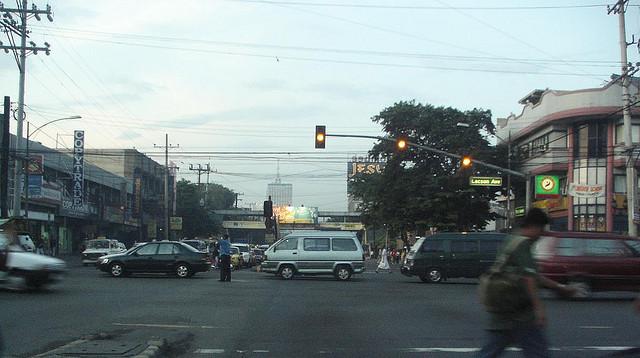Is it morning or evening in the picture?
Give a very brief answer. Evening. Is this street extremely busy?
Write a very short answer. Yes. What color is the traffic signal?
Answer briefly. Yellow. Is it raining?
Quick response, please. No. What color is the car in front of the black one?
Write a very short answer. Silver. 